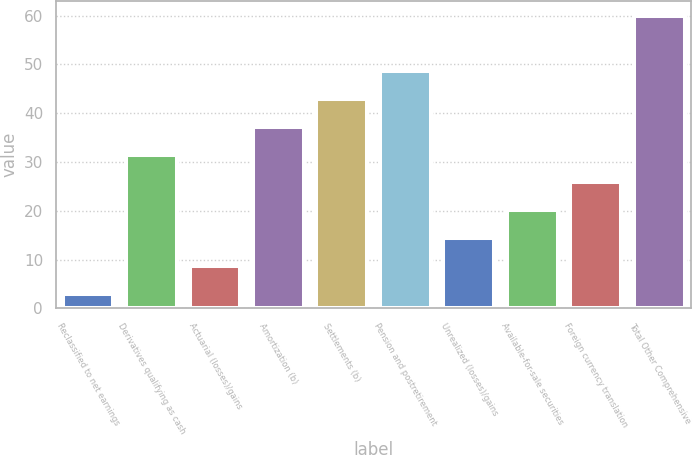<chart> <loc_0><loc_0><loc_500><loc_500><bar_chart><fcel>Reclassified to net earnings<fcel>Derivatives qualifying as cash<fcel>Actuarial (losses)/gains<fcel>Amortization (b)<fcel>Settlements (b)<fcel>Pension and postretirement<fcel>Unrealized (losses)/gains<fcel>Available-for-sale securities<fcel>Foreign currency translation<fcel>Total Other Comprehensive<nl><fcel>3<fcel>31.5<fcel>8.7<fcel>37.2<fcel>42.9<fcel>48.6<fcel>14.4<fcel>20.1<fcel>25.8<fcel>60<nl></chart> 